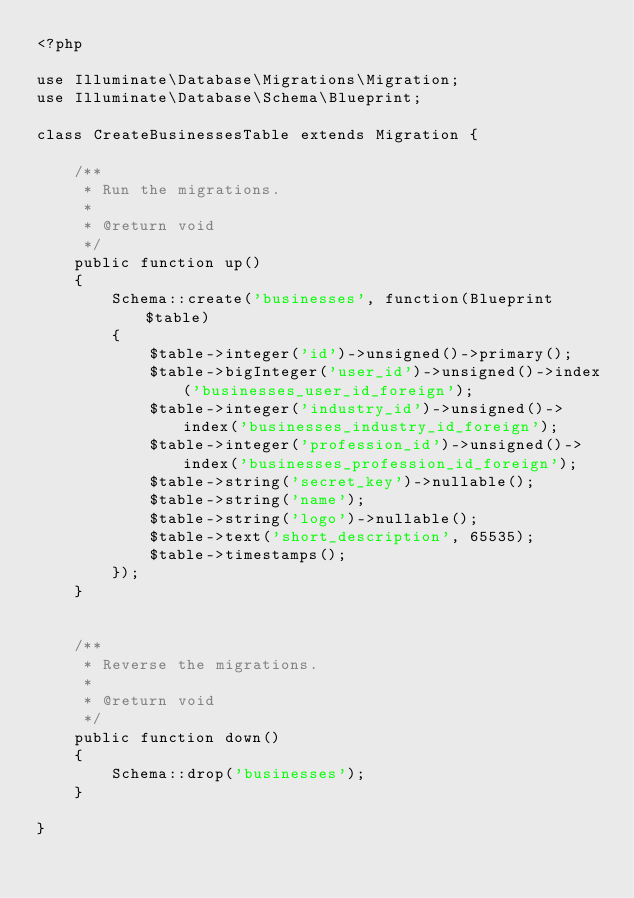Convert code to text. <code><loc_0><loc_0><loc_500><loc_500><_PHP_><?php

use Illuminate\Database\Migrations\Migration;
use Illuminate\Database\Schema\Blueprint;

class CreateBusinessesTable extends Migration {

	/**
	 * Run the migrations.
	 *
	 * @return void
	 */
	public function up()
	{
		Schema::create('businesses', function(Blueprint $table)
		{
			$table->integer('id')->unsigned()->primary();
			$table->bigInteger('user_id')->unsigned()->index('businesses_user_id_foreign');
			$table->integer('industry_id')->unsigned()->index('businesses_industry_id_foreign');
			$table->integer('profession_id')->unsigned()->index('businesses_profession_id_foreign');
			$table->string('secret_key')->nullable();
			$table->string('name');
			$table->string('logo')->nullable();
			$table->text('short_description', 65535);
			$table->timestamps();
		});
	}


	/**
	 * Reverse the migrations.
	 *
	 * @return void
	 */
	public function down()
	{
		Schema::drop('businesses');
	}

}
</code> 